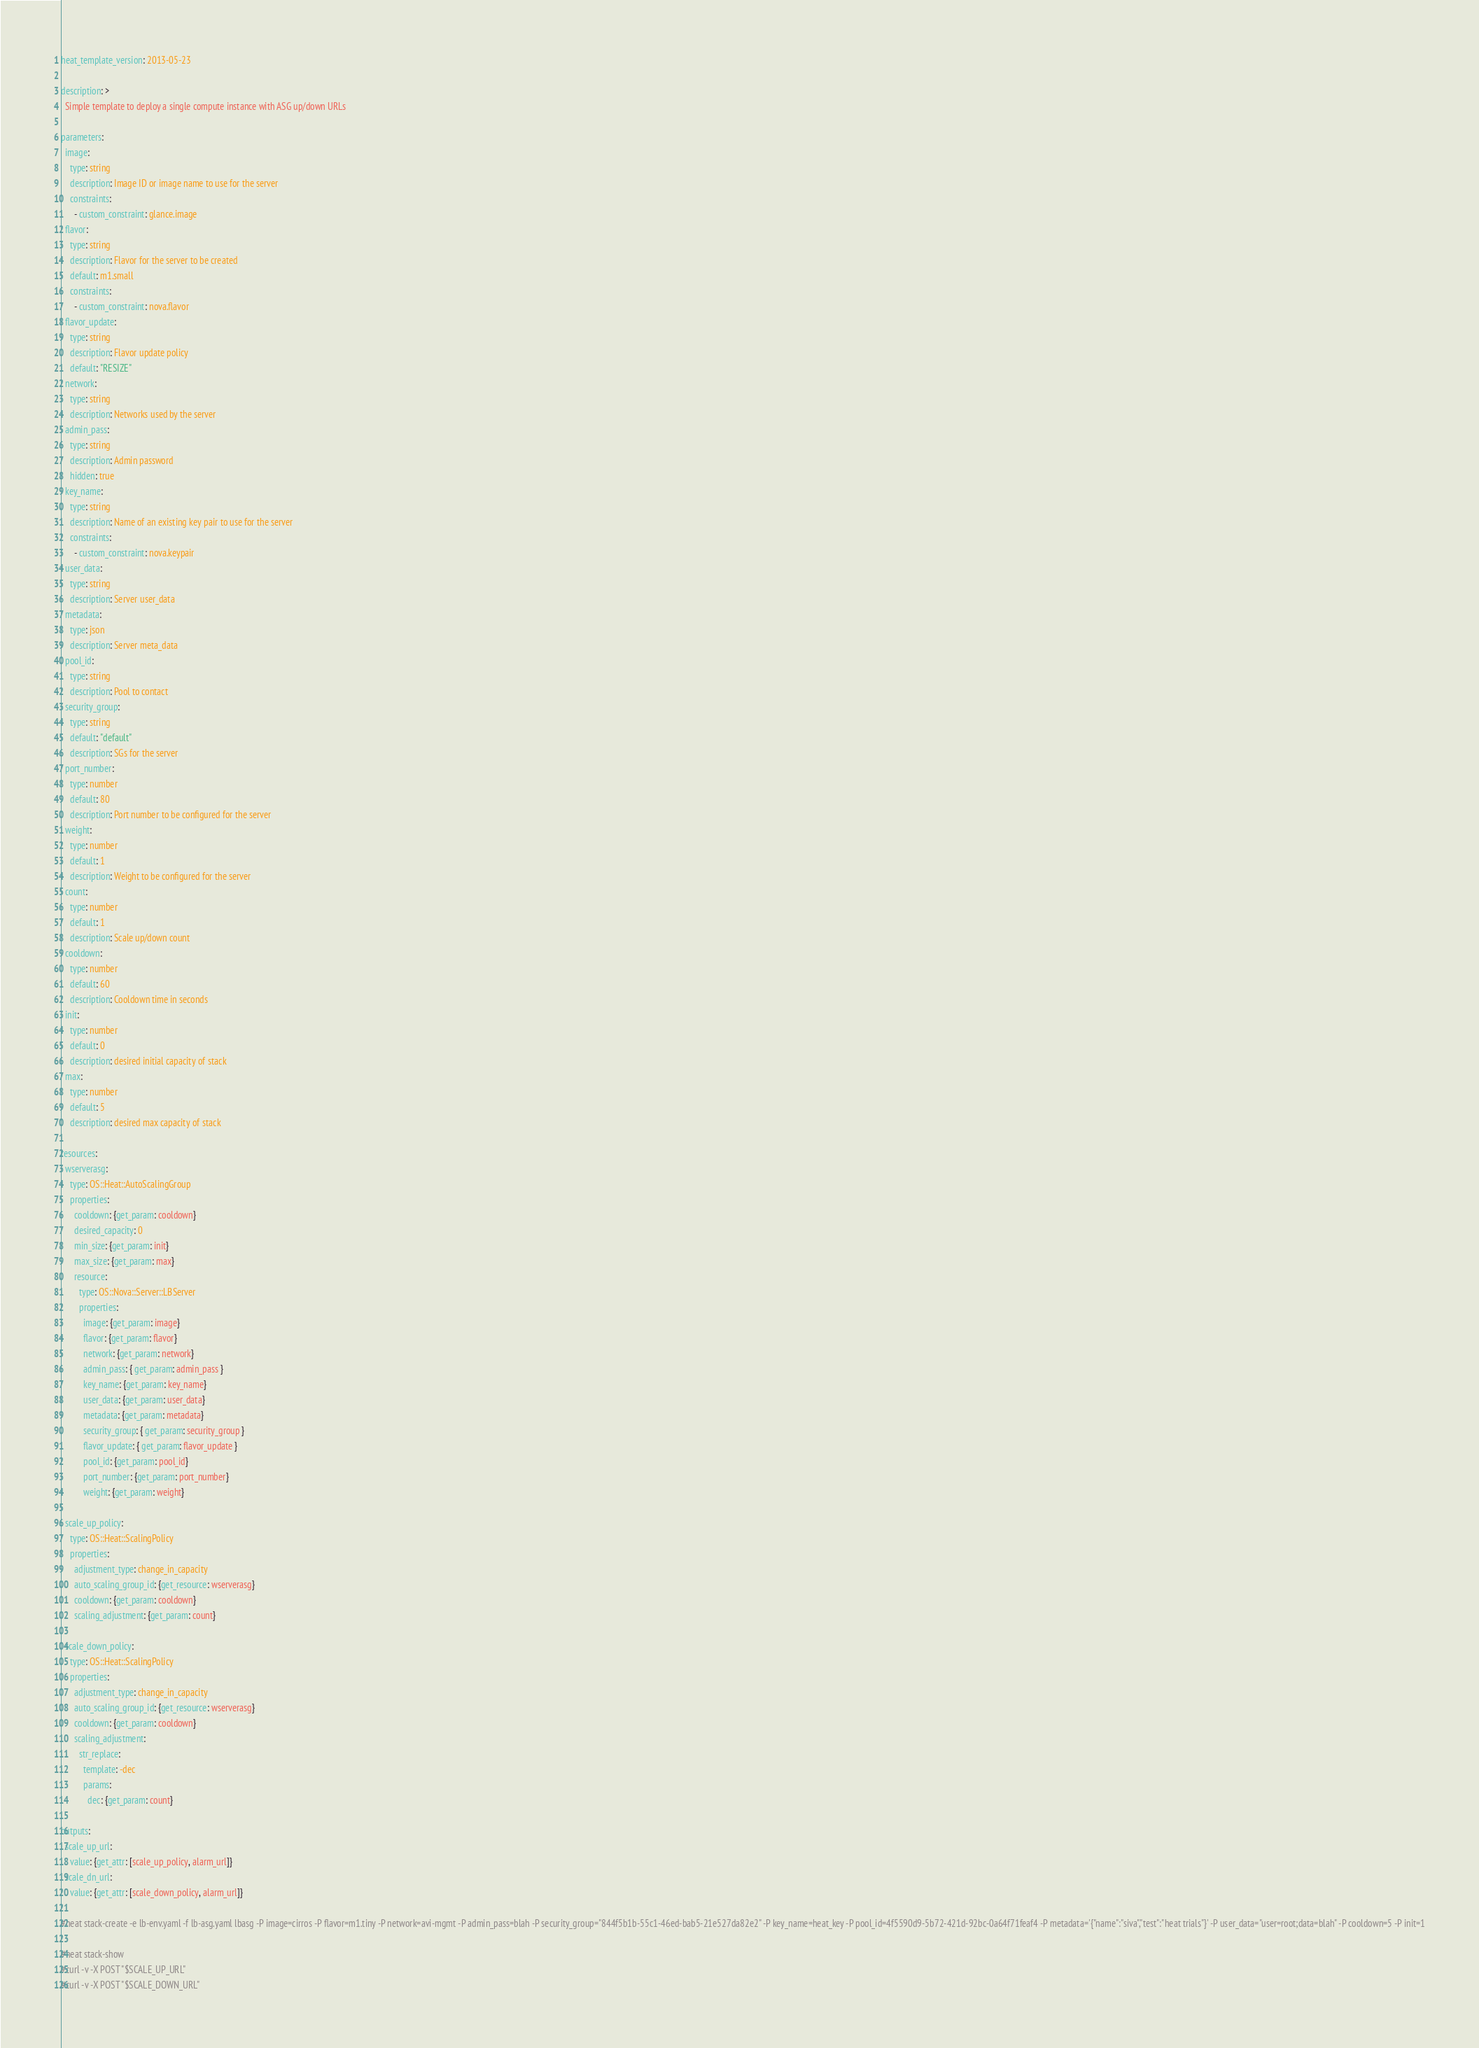Convert code to text. <code><loc_0><loc_0><loc_500><loc_500><_YAML_>heat_template_version: 2013-05-23

description: >
  Simple template to deploy a single compute instance with ASG up/down URLs

parameters:
  image:
    type: string
    description: Image ID or image name to use for the server
    constraints:
      - custom_constraint: glance.image
  flavor:
    type: string
    description: Flavor for the server to be created
    default: m1.small
    constraints:
      - custom_constraint: nova.flavor
  flavor_update:
    type: string
    description: Flavor update policy
    default: "RESIZE"
  network:
    type: string
    description: Networks used by the server 
  admin_pass:
    type: string
    description: Admin password
    hidden: true
  key_name:
    type: string
    description: Name of an existing key pair to use for the server
    constraints:
      - custom_constraint: nova.keypair
  user_data:
    type: string
    description: Server user_data
  metadata:
    type: json
    description: Server meta_data
  pool_id:
    type: string
    description: Pool to contact
  security_group:
    type: string
    default: "default"
    description: SGs for the server
  port_number:
    type: number
    default: 80
    description: Port number to be configured for the server
  weight:
    type: number
    default: 1
    description: Weight to be configured for the server
  count:
    type: number
    default: 1
    description: Scale up/down count
  cooldown:
    type: number
    default: 60
    description: Cooldown time in seconds
  init:
    type: number
    default: 0
    description: desired initial capacity of stack
  max:
    type: number
    default: 5
    description: desired max capacity of stack
    
resources:
  wserverasg:
    type: OS::Heat::AutoScalingGroup
    properties:
      cooldown: {get_param: cooldown}
      desired_capacity: 0
      min_size: {get_param: init}
      max_size: {get_param: max}
      resource:
        type: OS::Nova::Server::LBServer
        properties:
          image: {get_param: image}
          flavor: {get_param: flavor}
          network: {get_param: network}
          admin_pass: { get_param: admin_pass }
          key_name: {get_param: key_name}
          user_data: {get_param: user_data}
          metadata: {get_param: metadata}
          security_group: { get_param: security_group }
          flavor_update: { get_param: flavor_update }
          pool_id: {get_param: pool_id}
          port_number: {get_param: port_number}
          weight: {get_param: weight}

  scale_up_policy:
    type: OS::Heat::ScalingPolicy
    properties:
      adjustment_type: change_in_capacity
      auto_scaling_group_id: {get_resource: wserverasg}
      cooldown: {get_param: cooldown}
      scaling_adjustment: {get_param: count}

  scale_down_policy:
    type: OS::Heat::ScalingPolicy
    properties:
      adjustment_type: change_in_capacity
      auto_scaling_group_id: {get_resource: wserverasg}
      cooldown: {get_param: cooldown}
      scaling_adjustment: 
        str_replace:
          template: -dec
          params:
            dec: {get_param: count}

outputs:
  scale_up_url:
    value: {get_attr: [scale_up_policy, alarm_url]}
  scale_dn_url:
    value: {get_attr: [scale_down_policy, alarm_url]}

#heat stack-create -e lb-env.yaml -f lb-asg.yaml lbasg -P image=cirros -P flavor=m1.tiny -P network=avi-mgmt -P admin_pass=blah -P security_group="844f5b1b-55c1-46ed-bab5-21e527da82e2" -P key_name=heat_key -P pool_id=4f5590d9-5b72-421d-92bc-0a64f71feaf4 -P metadata='{"name":"siva","test":"heat trials"}' -P user_data="user=root;data=blah" -P cooldown=5 -P init=1

#heat stack-show
#curl -v -X POST "$SCALE_UP_URL"
#curl -v -X POST "$SCALE_DOWN_URL"</code> 